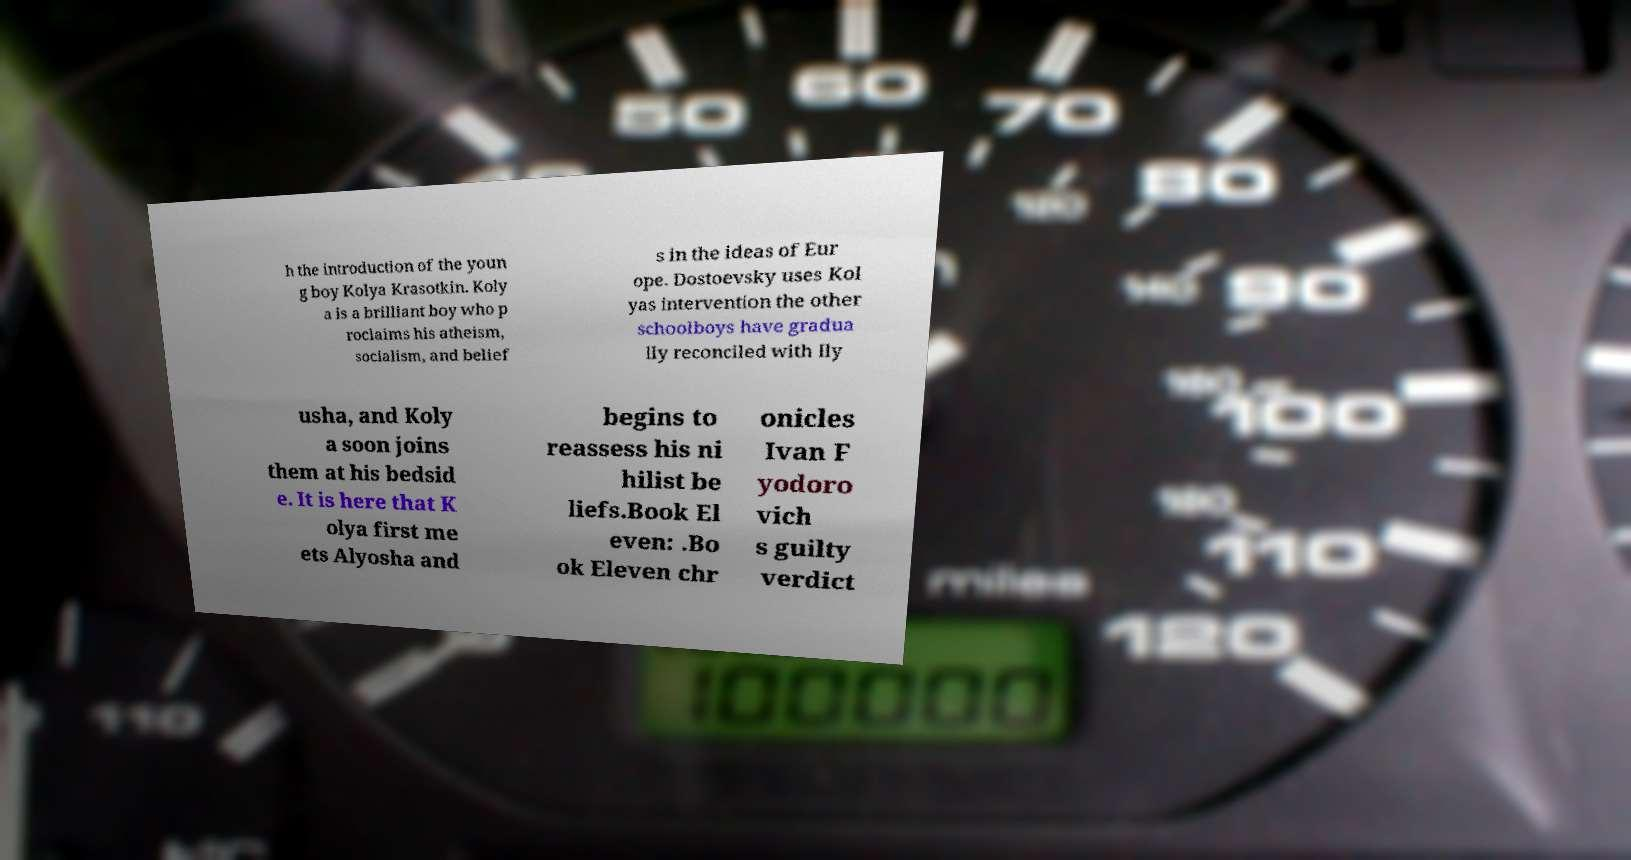Could you assist in decoding the text presented in this image and type it out clearly? h the introduction of the youn g boy Kolya Krasotkin. Koly a is a brilliant boy who p roclaims his atheism, socialism, and belief s in the ideas of Eur ope. Dostoevsky uses Kol yas intervention the other schoolboys have gradua lly reconciled with Ily usha, and Koly a soon joins them at his bedsid e. It is here that K olya first me ets Alyosha and begins to reassess his ni hilist be liefs.Book El even: .Bo ok Eleven chr onicles Ivan F yodoro vich s guilty verdict 